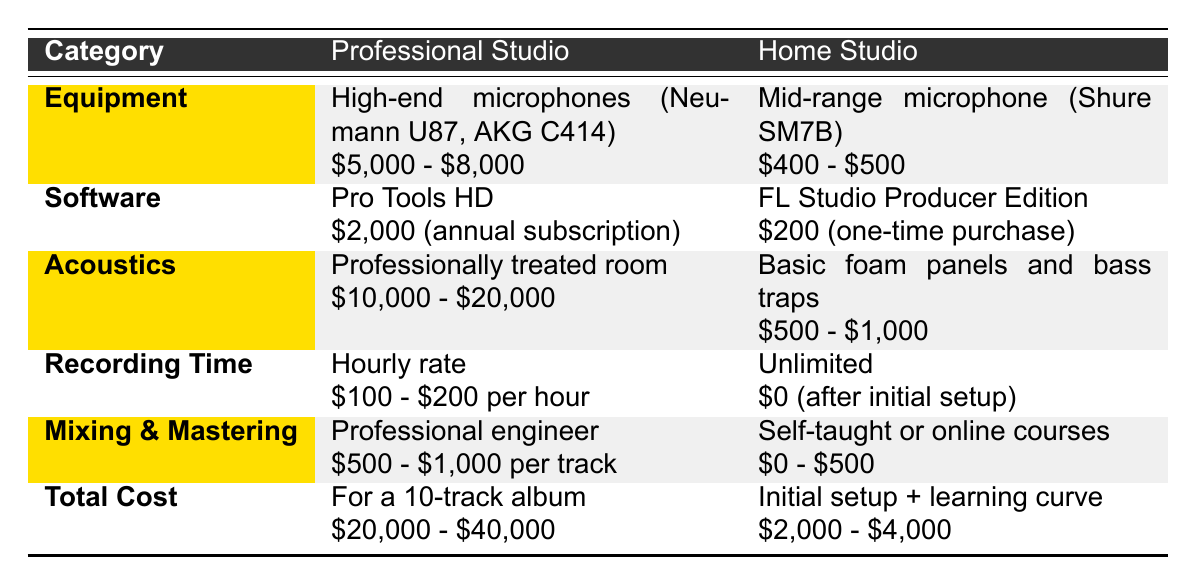What is the cost range of the high-end microphones in a professional studio? The table states the cost range for high-end microphones is between $5,000 and $8,000.
Answer: $5,000 - $8,000 How much does the FL Studio Producer Edition cost as a one-time purchase? According to the table, FL Studio Producer Edition costs $200 as a one-time purchase.
Answer: $200 What is the total cost range for a 10-track album in a professional studio? The total cost for a 10-track album in a professional studio is listed as $20,000 to $40,000.
Answer: $20,000 - $40,000 Is the cost for mixing and mastering in a home studio higher than in a professional studio? The table shows that mixing and mastering in a home studio can range from $0 to $500, while in a professional studio it ranges from $500 to $1,000 per track. Therefore, this statement is false.
Answer: No What is the difference in recording time costs between a professional studio and a home studio? In a professional studio, recording time costs $100 to $200 per hour, whereas it is $0 after the initial setup in a home studio. The difference can be calculated as $100 to $200 per hour versus $0, meaning the professional studio costs significantly more.
Answer: $100 to $200 per hour If you spend the highest amount on mixing and mastering in a professional studio per track, what will be the cost for 10 tracks? The highest amount for mixing and mastering in a professional studio is $1,000 per track. Therefore, for 10 tracks, it would be $1,000 multiplied by 10, resulting in $10,000.
Answer: $10,000 In terms of acoustics, how much can you save by setting up a home studio instead of a professional studio at the maximum cost? The maximum cost for acoustics in a professional studio is $20,000, while the maximum cost for home studio acoustics is $1,000. The savings can be calculated as $20,000 - $1,000, which equals $19,000.
Answer: $19,000 Does a professional studio provide better acoustics compared to a home studio? Yes, according to the table, professional studios have professionally treated rooms, while home studios use basic foam panels and bass traps, indicating that professional studios provide better acoustics.
Answer: Yes What is the total setup cost range for a home studio compared to a professional studio? The total setup cost range for a home studio is $2,000 to $4,000, while for a professional studio it is $20,000 to $40,000. This shows that home studios are significantly less expensive to set up.
Answer: Home studio: $2,000 - $4,000; Professional studio: $20,000 - $40,000 